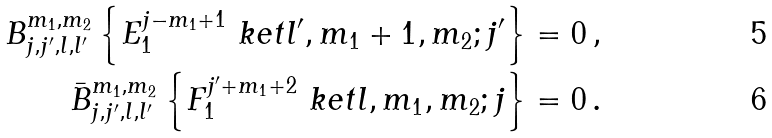Convert formula to latex. <formula><loc_0><loc_0><loc_500><loc_500>B _ { j , j ^ { \prime } , l , l ^ { \prime } } ^ { m _ { 1 } , m _ { 2 } } \left \{ E _ { 1 } ^ { j - m _ { 1 } + 1 } \ k e t { l ^ { \prime } , m _ { 1 } + 1 , m _ { 2 } ; j ^ { \prime } } \right \} & = 0 \, , \\ \bar { B } _ { j , j ^ { \prime } , l , l ^ { \prime } } ^ { m _ { 1 } , m _ { 2 } } \left \{ F _ { 1 } ^ { j ^ { \prime } + m _ { 1 } + 2 } \ k e t { l , m _ { 1 } , m _ { 2 } ; j } \right \} & = 0 \, .</formula> 